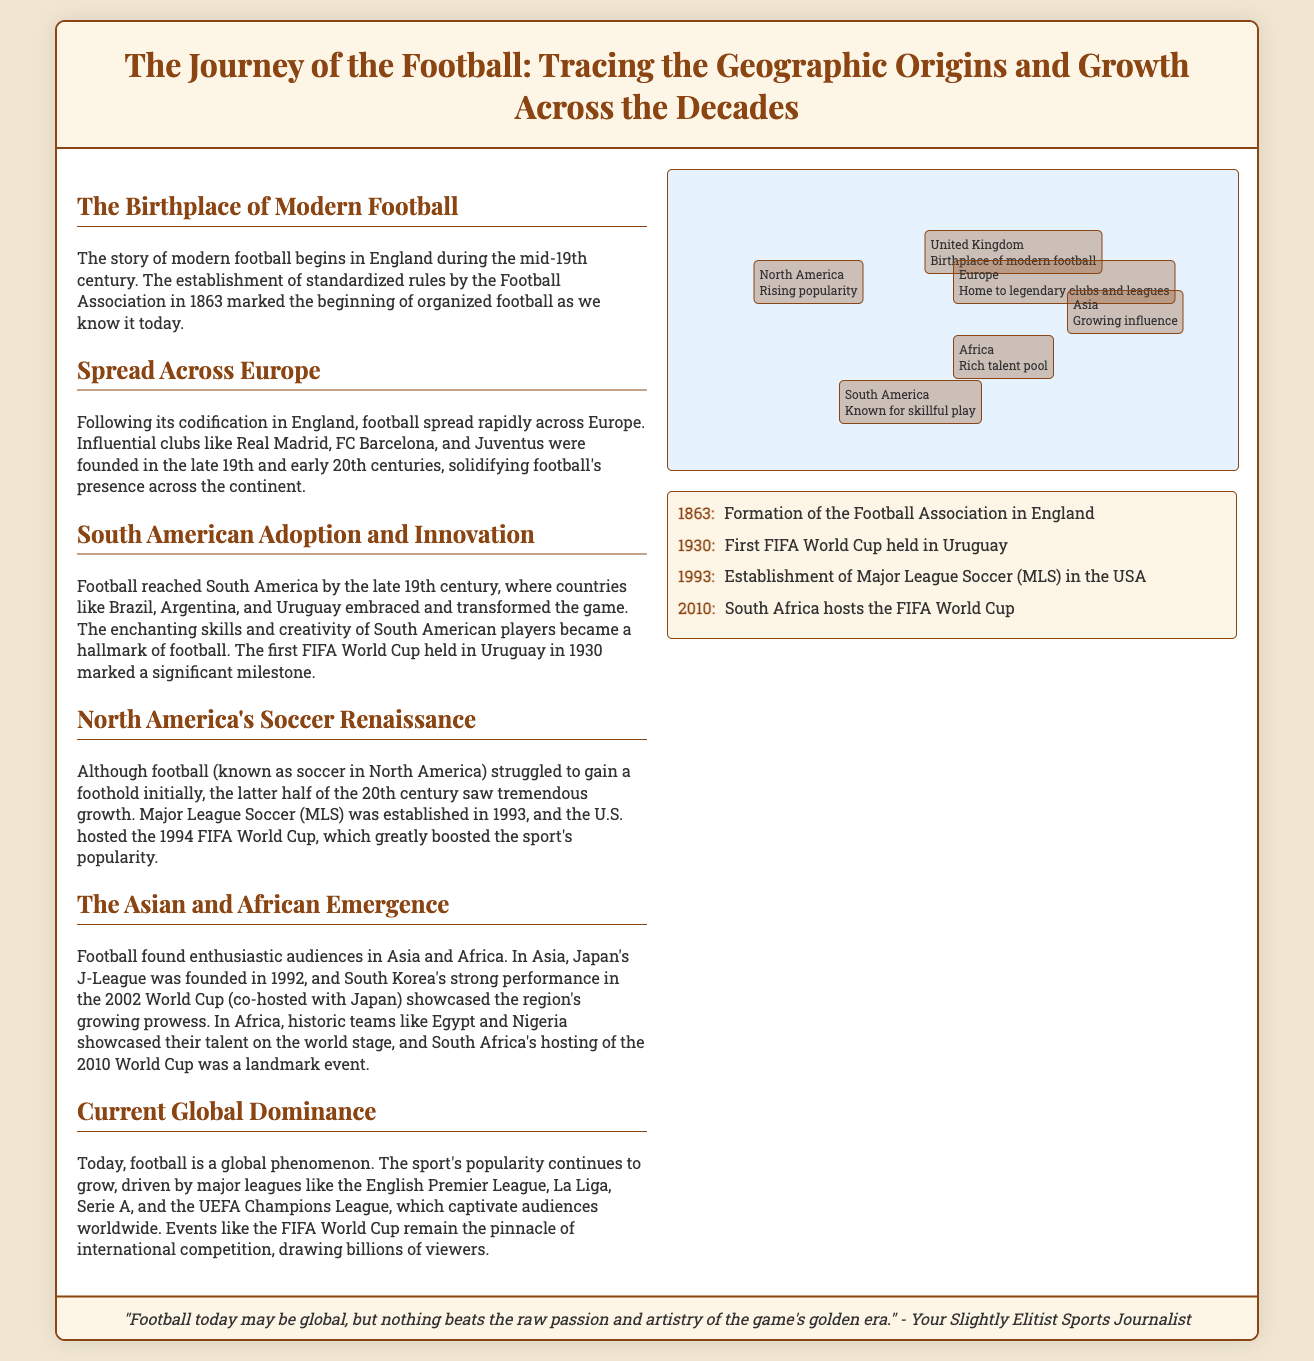What year was the Football Association formed? The timeline indicates that the Football Association was formed in 1863.
Answer: 1863 Which continent is referred to as the birthplace of modern football? The text mentions that the United Kingdom is the birthplace of modern football.
Answer: United Kingdom What significant event occurred in 1930? The timeline states that the first FIFA World Cup was held in Uruguay in 1930.
Answer: First FIFA World Cup Which league was established in 1993? The document indicates that Major League Soccer (MLS) was established in the USA in 1993.
Answer: Major League Soccer What is a key feature of South American football according to the infographic? The text describes South American football as being known for skillful play.
Answer: Skillful play Which country hosted the FIFA World Cup in 2010? The document states that South Africa hosted the FIFA World Cup in 2010.
Answer: South Africa What type of content does the map provide? The map illustrates the geographic spread of football and its regions of prominence as per the document.
Answer: Geographic spread Which club is mentioned as an influential European club? The text mentions Real Madrid as one of the influential clubs in Europe.
Answer: Real Madrid What does the document say about football's global status today? It notes that football is a global phenomenon with growing popularity.
Answer: Global phenomenon 